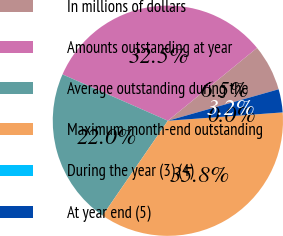Convert chart to OTSL. <chart><loc_0><loc_0><loc_500><loc_500><pie_chart><fcel>In millions of dollars<fcel>Amounts outstanding at year<fcel>Average outstanding during the<fcel>Maximum month-end outstanding<fcel>During the year (3) (4)<fcel>At year end (5)<nl><fcel>6.5%<fcel>32.5%<fcel>22.0%<fcel>35.75%<fcel>0.0%<fcel>3.25%<nl></chart> 